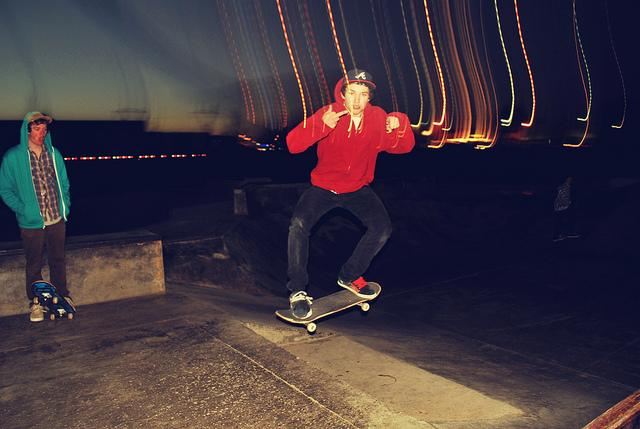The boy skateboarding is a fan of what baseball team? astros 